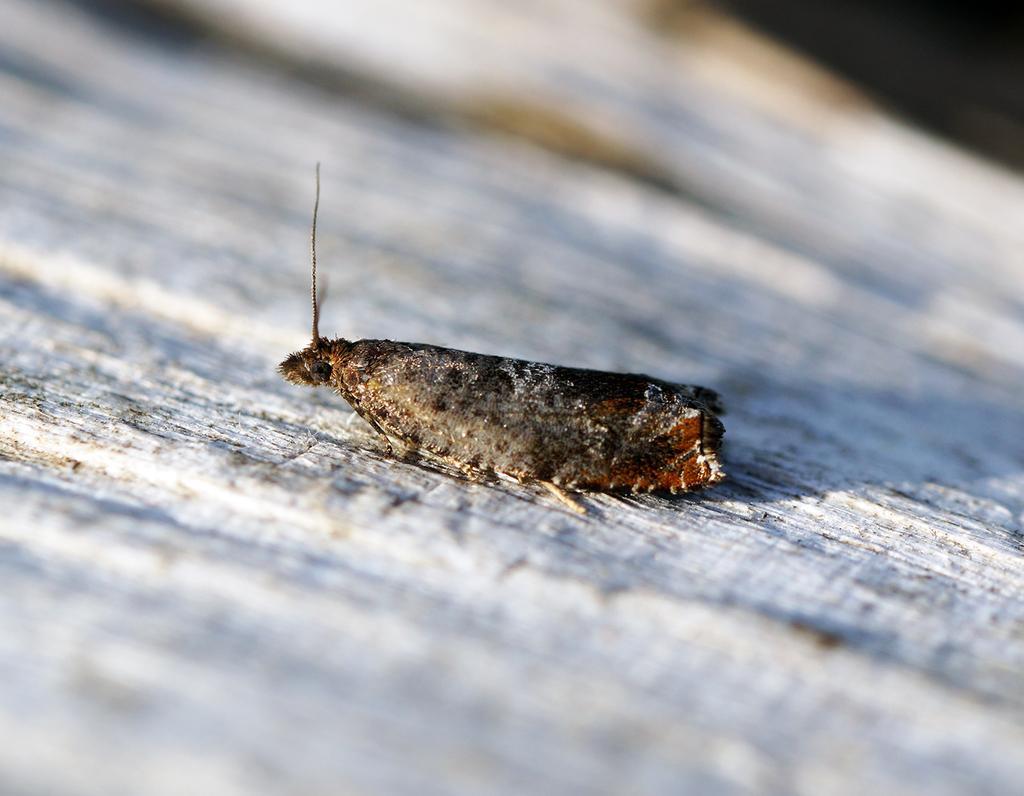How would you summarize this image in a sentence or two? In this picture there is a moth in the center of the image. 